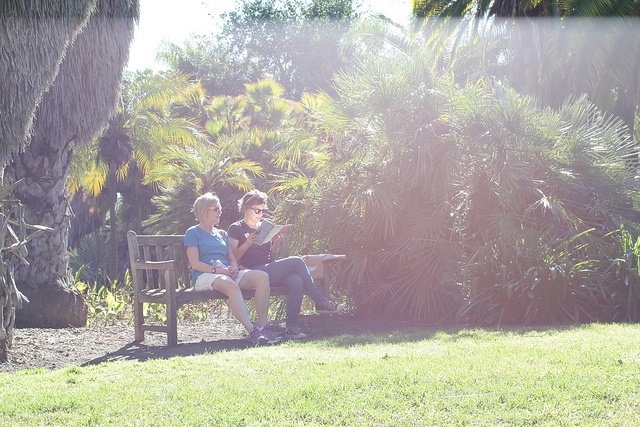Describe the objects in this image and their specific colors. I can see bench in blue and gray tones, people in blue, darkgray, gray, and lightgray tones, people in blue, gray, and lightgray tones, bench in blue and gray tones, and handbag in blue, darkgray, lightgray, and gray tones in this image. 